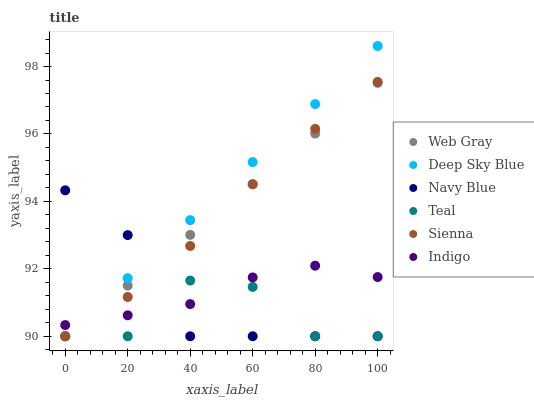Does Teal have the minimum area under the curve?
Answer yes or no. Yes. Does Deep Sky Blue have the maximum area under the curve?
Answer yes or no. Yes. Does Indigo have the minimum area under the curve?
Answer yes or no. No. Does Indigo have the maximum area under the curve?
Answer yes or no. No. Is Deep Sky Blue the smoothest?
Answer yes or no. Yes. Is Teal the roughest?
Answer yes or no. Yes. Is Indigo the smoothest?
Answer yes or no. No. Is Indigo the roughest?
Answer yes or no. No. Does Web Gray have the lowest value?
Answer yes or no. Yes. Does Indigo have the lowest value?
Answer yes or no. No. Does Deep Sky Blue have the highest value?
Answer yes or no. Yes. Does Indigo have the highest value?
Answer yes or no. No. Does Web Gray intersect Navy Blue?
Answer yes or no. Yes. Is Web Gray less than Navy Blue?
Answer yes or no. No. Is Web Gray greater than Navy Blue?
Answer yes or no. No. 